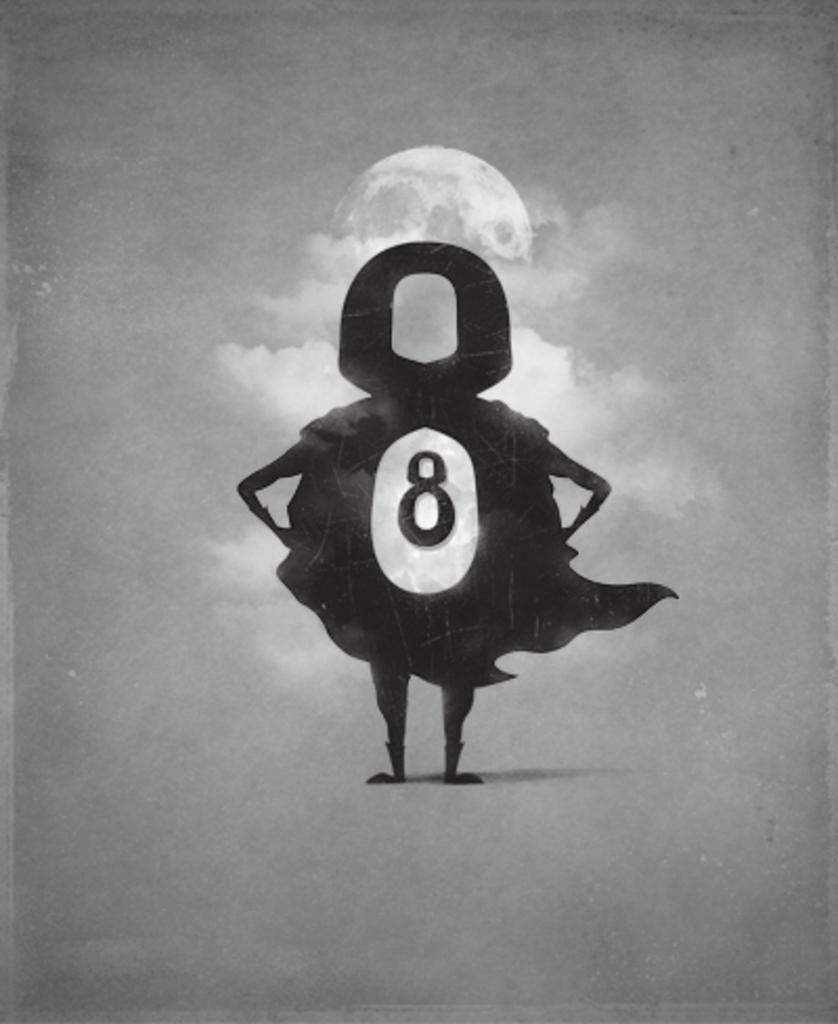What is the color scheme of the image? The image is black and white. What is the main subject in the middle of the image? There is a cartoon image in the middle of the image. What can be seen in the background of the image? The background of the image appears to be the sky. How many veins can be seen in the cartoon image? There are no veins present in the cartoon image, as it is not a realistic depiction of a living organism. 